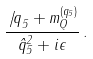<formula> <loc_0><loc_0><loc_500><loc_500>\frac { \not { \, q } _ { 5 } + m _ { Q } ^ { ( q _ { 5 } ) } } { \hat { q } _ { 5 } ^ { 2 } + i \epsilon } \, .</formula> 